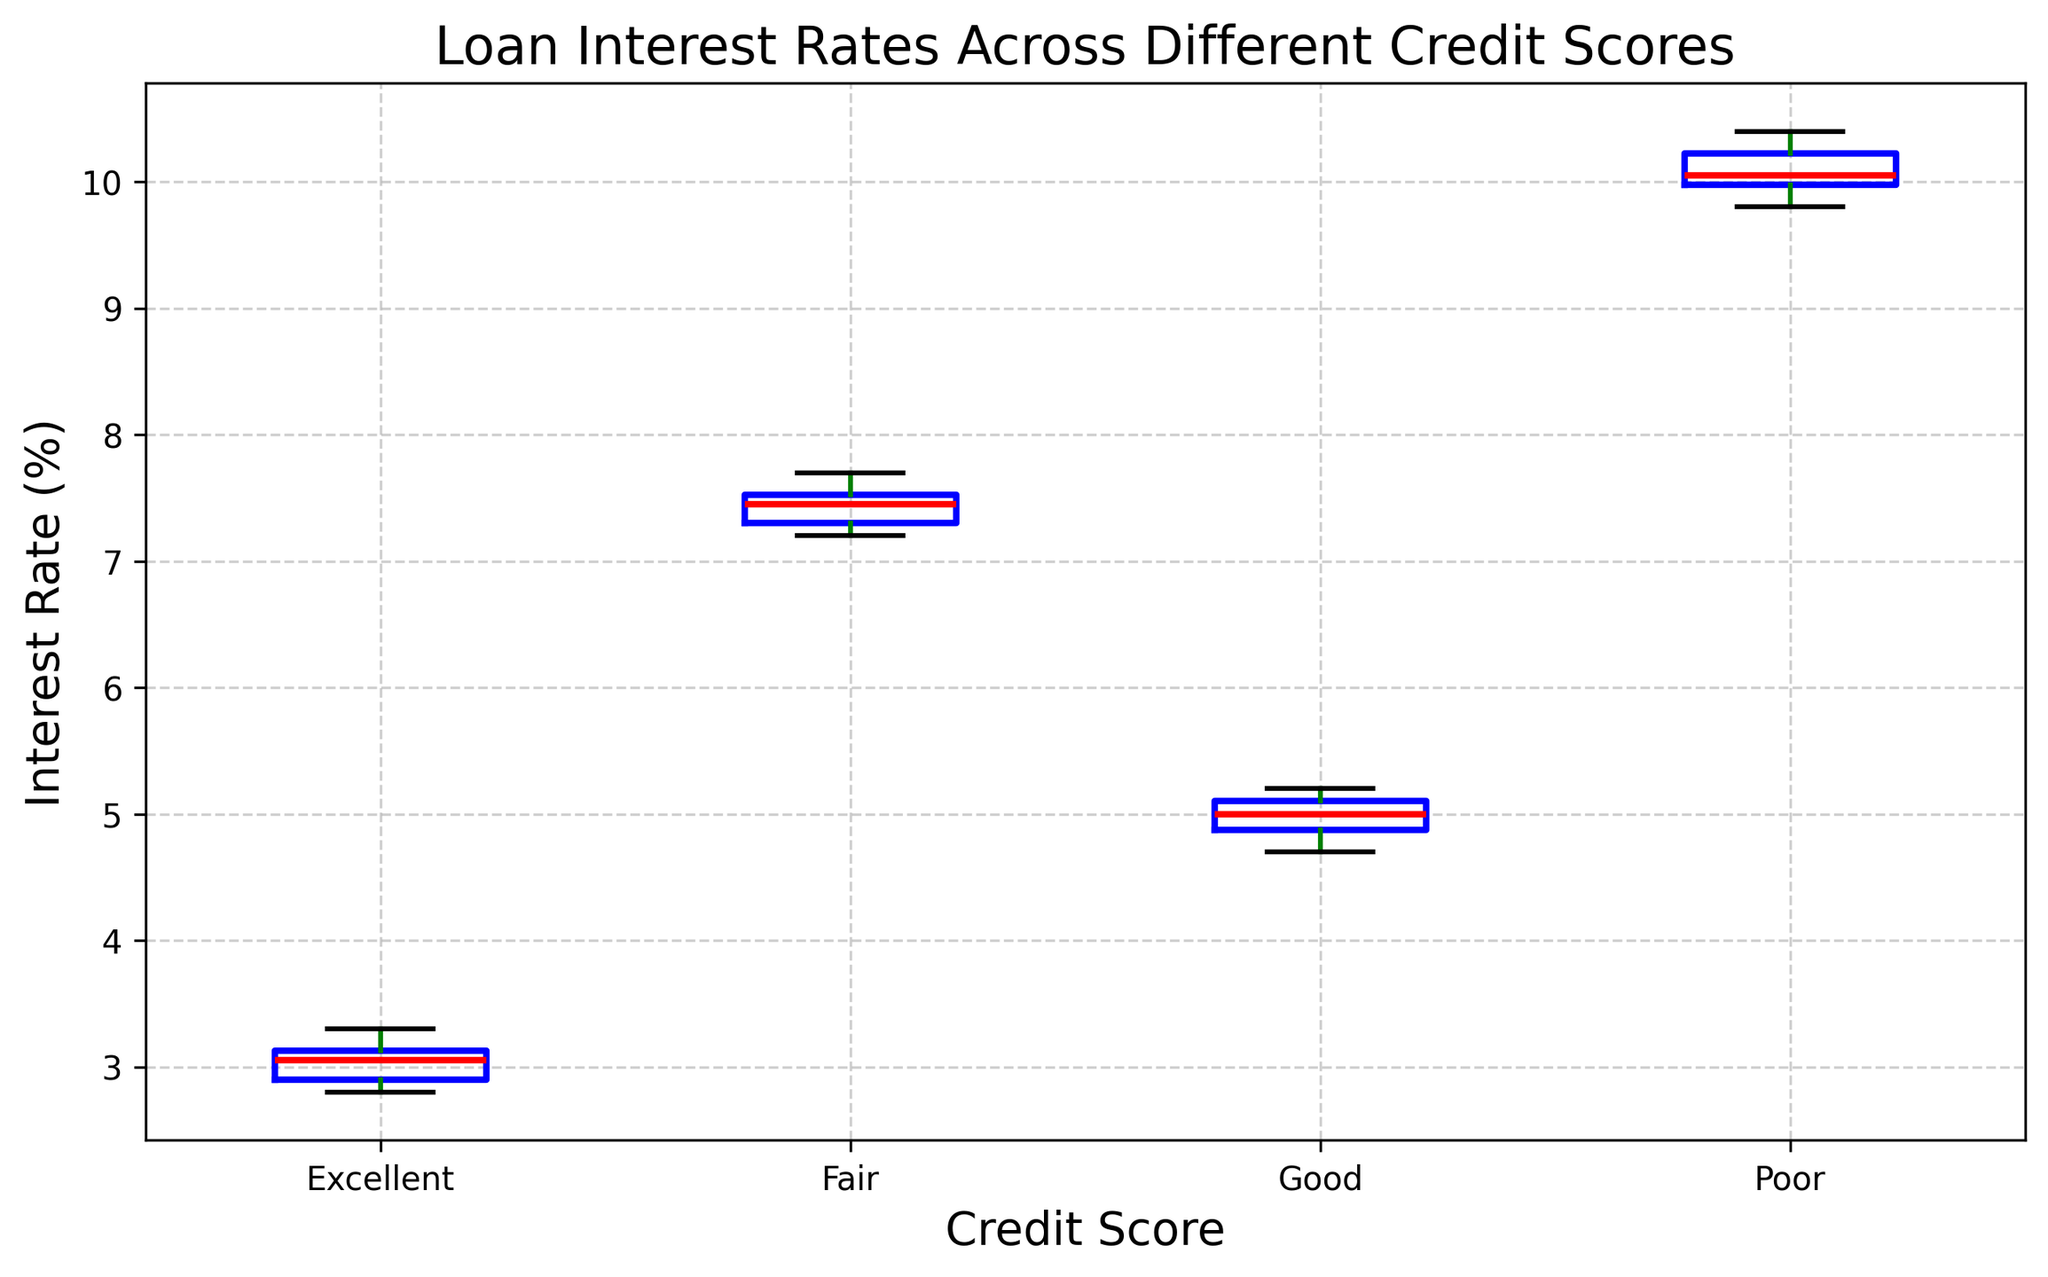What is the median interest rate for the 'Good' credit score group? To find the median, locate the middle value in the sorted list of interest rates for the 'Good' credit score group. For 'Good', the sorted rates are 4.7, 4.8, 4.9, 5.0, 5.0, 5.1, 5.1, 5.2. The middle values are 5.0 and 5.0, so the average is (5.0 + 5.0)/2. Therefore, the median is 5.0.
Answer: 5.0 Which credit score group has the highest median interest rate? To determine this, find the median interest rate for each credit score group and compare them. The medians for the groups are: 'Excellent' - 3.0, 'Good' - 5.0, 'Fair' - 7.4, 'Poor' - 10.1. 'Poor' has the highest median interest rate.
Answer: Poor What is the interquartile range (IQR) of interest rates for the 'Fair' credit score group? Calculate the IQR by finding the difference between the 75th percentile (Q3) and the 25th percentile (Q1) of the 'Fair' interest rates. For 'Fair', the sorted data is 7.2, 7.3, 7.3, 7.4, 7.5, 7.5, 7.6, 7.7. Q1 (25th percentile) is the 2nd value 7.3, and Q3 (75th percentile) is the 6th value 7.5. Therefore, IQR = Q3 - Q1 = 7.5 - 7.3.
Answer: 0.2 Which credit score group has the smallest range of interest rates? Calculate the ranges by subtracting the minimum value from the maximum value for each group. 'Excellent' ranges from 2.8 to 3.3, 'Good' from 4.7 to 5.2, 'Fair' from 7.2 to 7.7, 'Poor' from 9.8 to 10.4. 'Excellent' has the smallest range of 3.3 - 2.8 = 0.5.
Answer: Excellent Are there any outliers in the 'Good' credit score group? Identify outliers by finding values that lie outside 1.5 times the interquartile range (IQR) above Q3 and below Q1. As calculated, the IQR for 'Good' is 5.2 - 4.7 = 0.5. Using the boundaries: Upper = 5.2 + 1.5*0.5 = 5.95, and Lower = 4.7 - 1.5*0.5 = 4.05. There are no rates outside 4.05 - 5.95 range, so no outliers.
Answer: No Which color represents the median interest rate line in the box plots? The box plot shows the median interest rate line as red.
Answer: Red How does the range of interest rates for the 'Poor' credit score group compare to the 'Fair' group? Compare the range (max-min) of both groups: 'Poor' (10.4 - 9.8 = 0.6) and 'Fair' (7.7 - 7.2 = 0.5). The range for 'Poor' is slightly larger at 0.6 compared to 0.5 for 'Fair'.
Answer: Poor has a larger range by 0.1 Which credit score group shows the highest variability in interest rates? Variability is indicated by the length of the box and whiskers. Comparing the spread, 'Poor' shows the highest variability as it has the longest box and whiskers.
Answer: Poor What is the 75th percentile of the interest rates for the 'Excellent' group? The 75th percentile (Q3) is found at the third quartile position. For 'Excellent', sorted data: 2.8, 2.9, 2.9, 3.0, 3.1, 3.1, 3.2, 3.3. Q3 is at the 6th data point, which is 3.1.
Answer: 3.1 